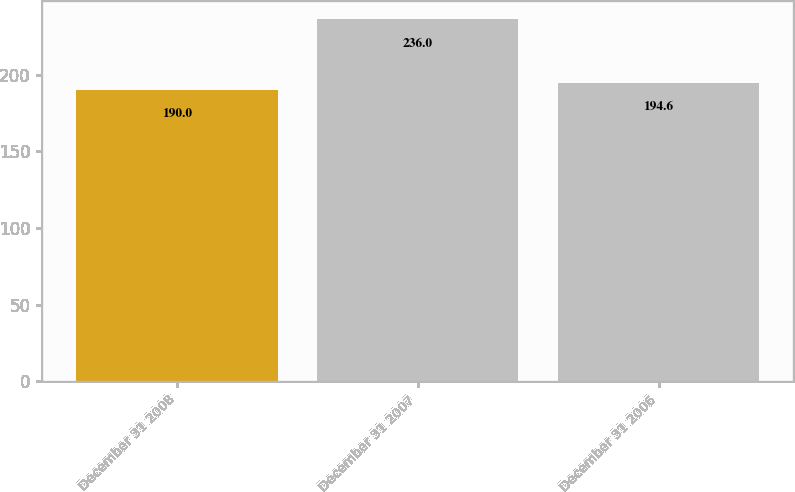Convert chart to OTSL. <chart><loc_0><loc_0><loc_500><loc_500><bar_chart><fcel>December 31 2008<fcel>December 31 2007<fcel>December 31 2006<nl><fcel>190<fcel>236<fcel>194.6<nl></chart> 